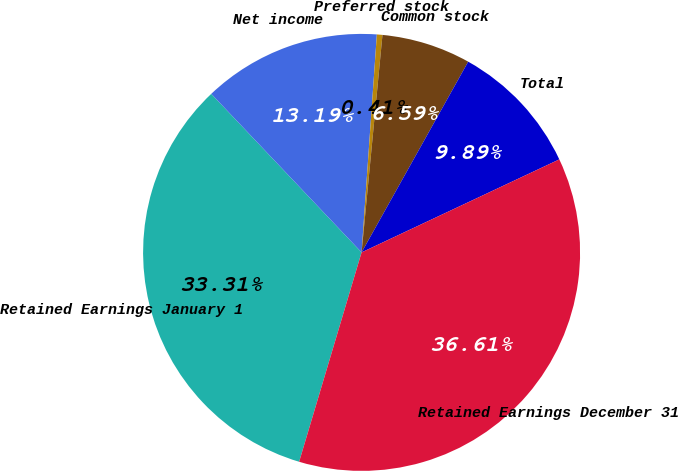<chart> <loc_0><loc_0><loc_500><loc_500><pie_chart><fcel>Retained Earnings January 1<fcel>Net income<fcel>Preferred stock<fcel>Common stock<fcel>Total<fcel>Retained Earnings December 31<nl><fcel>33.31%<fcel>13.19%<fcel>0.41%<fcel>6.59%<fcel>9.89%<fcel>36.61%<nl></chart> 